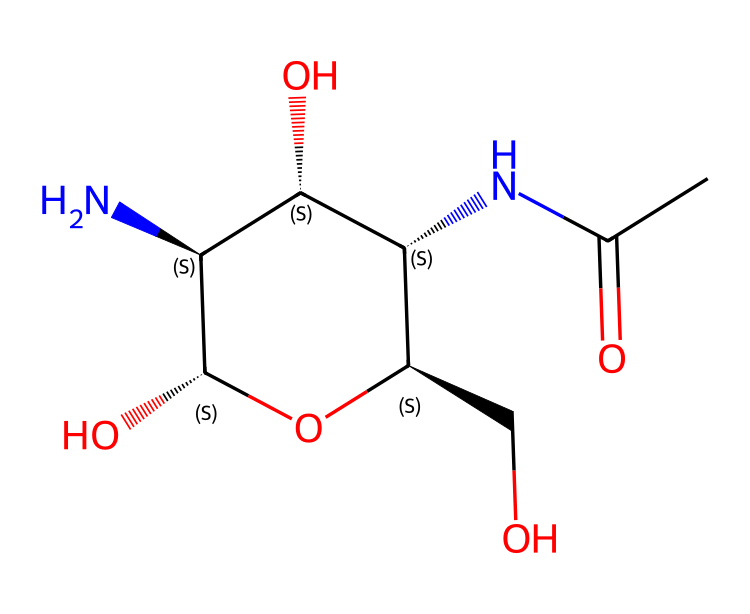What is the molecular formula of chitosan? The molecular formula can be derived from the SMILES representation by counting the number of each type of atom present in the structure. In this case, there are 8 carbon atoms (C), 13 hydrogen atoms (H), 2 nitrogen atoms (N), and 6 oxygen atoms (O), giving a molecular formula of C8H13N2O6.
Answer: C8H13N2O6 How many chiral centers does the chitosan molecule have? By analyzing the SMILES structure, chiral centers can be identified where a carbon atom is attached to four different substituents. In this structure, there are four carbon atoms that fit this criterion, indicating that the molecule has 4 chiral centers.
Answer: 4 What type of glycosidic linkage is present in chitosan? Chitosan is a polysaccharide formed by the linkage of N-acetylglucosamine units through β(1→4) glycosidic bonds. Observations of the structure reveal this specific type of linkage between the sugar components.
Answer: β(1→4) What functional groups are present in chitosan? The structure exhibits multiple functional groups, including hydroxyl (-OH) and amine (-NH2) groups. Observing the SMILES indicates the presence of these functional groups linked to the carbon skeleton of chitosan.
Answer: hydroxyl and amine How does the molecular structure of chitosan affect its solubility? The presence of multiple hydroxyl groups increases hydrogen bonding capacity with water, enhancing solubility in acidic environments despite its polymeric nature. This relationship between functional groups and solubility can be identified in the chemical structure.
Answer: increases solubility in acidic environments What is the primary use of chitosan in pharmaceuticals? Chitosan is primarily used as a coating material for drug delivery systems due to its biocompatibility and biodegradability. Analyzing applications seen in literature or product formulations confirms its role in pharmaceuticals.
Answer: drug delivery systems 